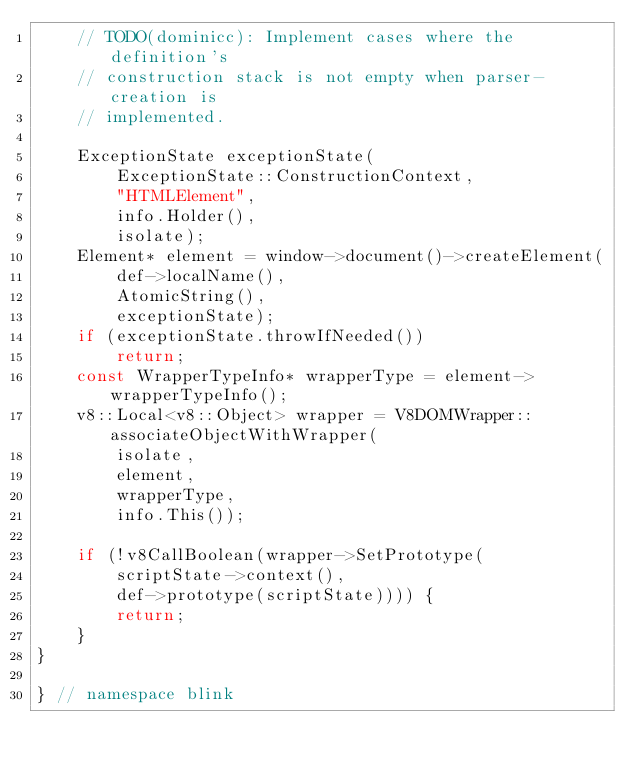<code> <loc_0><loc_0><loc_500><loc_500><_C++_>    // TODO(dominicc): Implement cases where the definition's
    // construction stack is not empty when parser-creation is
    // implemented.

    ExceptionState exceptionState(
        ExceptionState::ConstructionContext,
        "HTMLElement",
        info.Holder(),
        isolate);
    Element* element = window->document()->createElement(
        def->localName(),
        AtomicString(),
        exceptionState);
    if (exceptionState.throwIfNeeded())
        return;
    const WrapperTypeInfo* wrapperType = element->wrapperTypeInfo();
    v8::Local<v8::Object> wrapper = V8DOMWrapper::associateObjectWithWrapper(
        isolate,
        element,
        wrapperType,
        info.This());

    if (!v8CallBoolean(wrapper->SetPrototype(
        scriptState->context(),
        def->prototype(scriptState)))) {
        return;
    }
}

} // namespace blink
</code> 